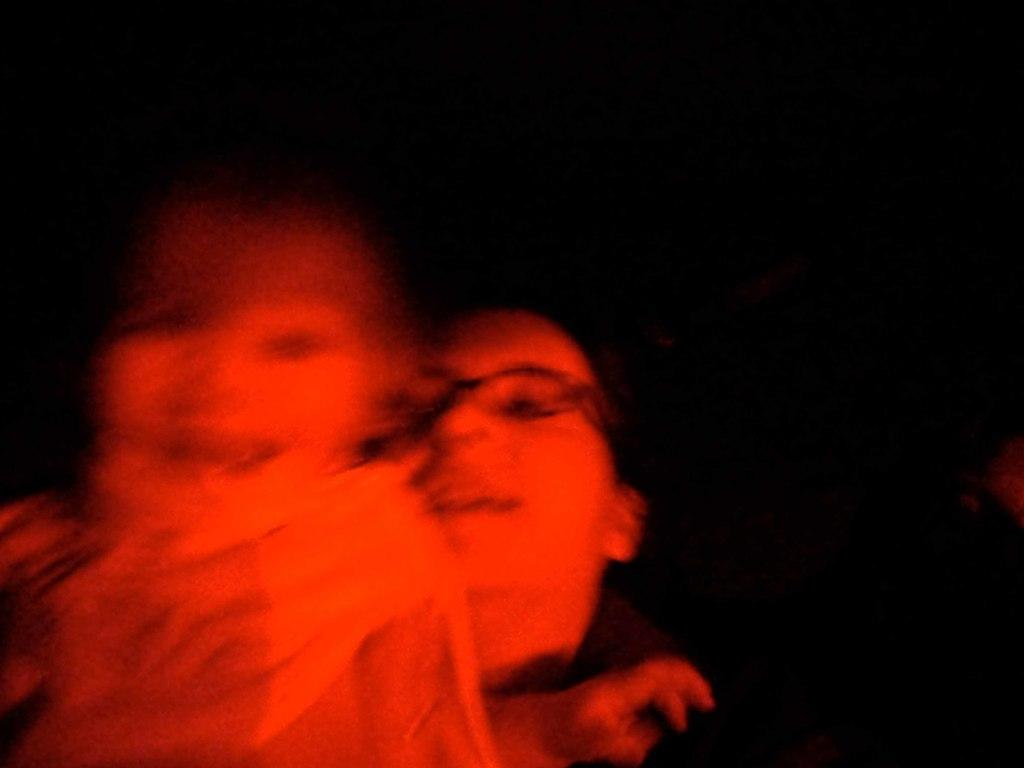What is the overall tone or appearance of the image? The image is dark. Who is present in the image? There is a woman in the image. What is the woman doing in the image? The woman is holding a kid. What type of effect does the wind have on the field in the image? There is no field or wind present in the image; it features a woman holding a kid in a dark setting. 